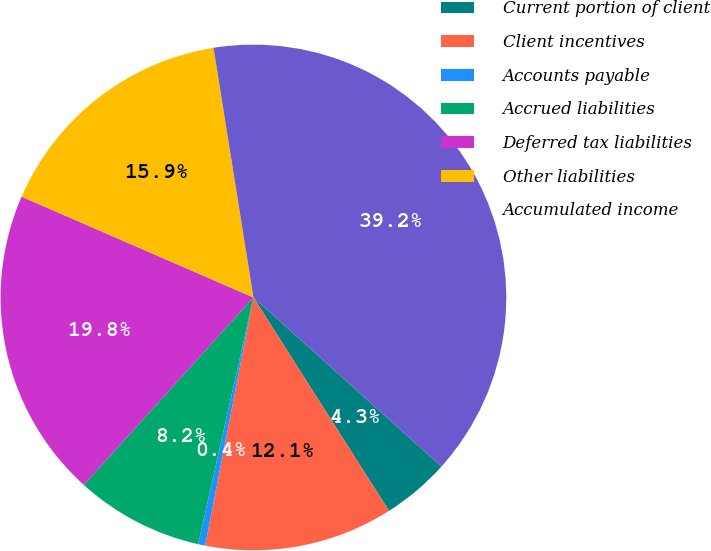Convert chart. <chart><loc_0><loc_0><loc_500><loc_500><pie_chart><fcel>Current portion of client<fcel>Client incentives<fcel>Accounts payable<fcel>Accrued liabilities<fcel>Deferred tax liabilities<fcel>Other liabilities<fcel>Accumulated income<nl><fcel>4.33%<fcel>12.07%<fcel>0.45%<fcel>8.2%<fcel>19.82%<fcel>15.95%<fcel>39.19%<nl></chart> 